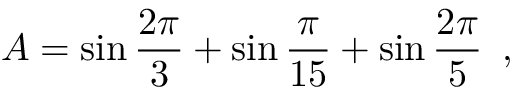Convert formula to latex. <formula><loc_0><loc_0><loc_500><loc_500>A = \sin \frac { 2 \pi } { 3 } + \sin \frac { \pi } { 1 5 } + \sin \frac { 2 \pi } { 5 } \, ,</formula> 